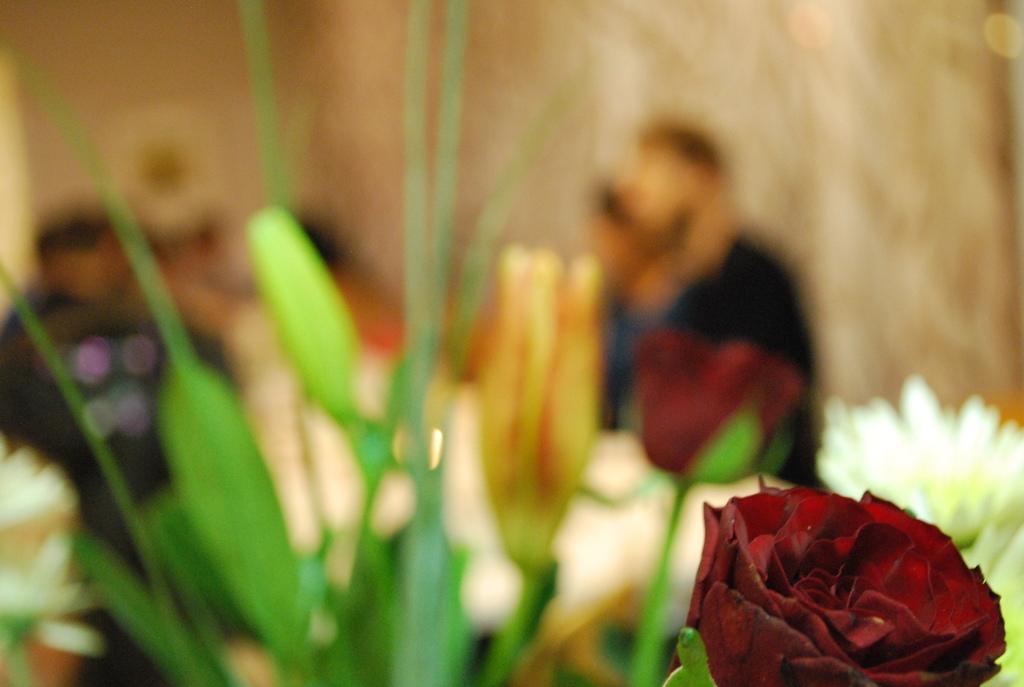How would you summarize this image in a sentence or two? In this image at the bottom we can see a flower. In the background the image is blur but we can see plants, flowers, few persons and objects. 